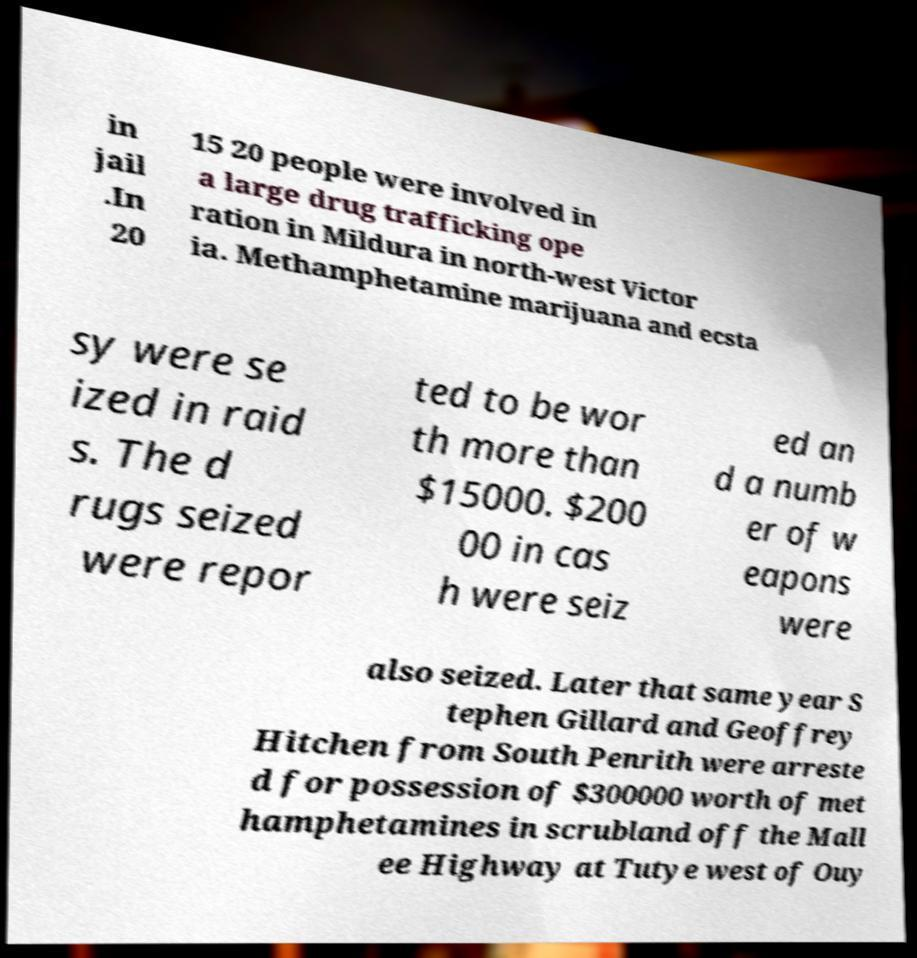I need the written content from this picture converted into text. Can you do that? in jail .In 20 15 20 people were involved in a large drug trafficking ope ration in Mildura in north-west Victor ia. Methamphetamine marijuana and ecsta sy were se ized in raid s. The d rugs seized were repor ted to be wor th more than $15000. $200 00 in cas h were seiz ed an d a numb er of w eapons were also seized. Later that same year S tephen Gillard and Geoffrey Hitchen from South Penrith were arreste d for possession of $300000 worth of met hamphetamines in scrubland off the Mall ee Highway at Tutye west of Ouy 